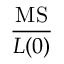<formula> <loc_0><loc_0><loc_500><loc_500>\frac { M S } { L ( 0 ) }</formula> 